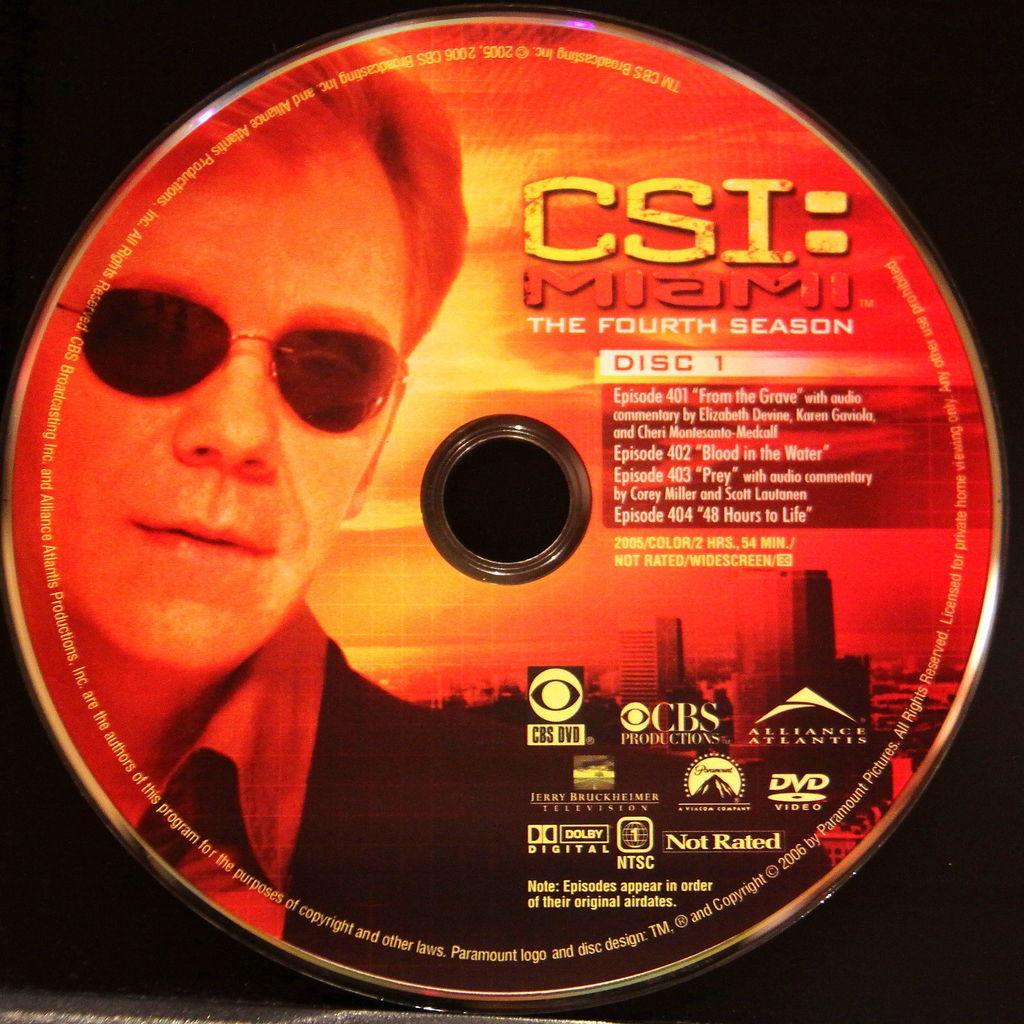In one or two sentences, can you explain what this image depicts? In the image there is a CD and on that CD there is a person´s picture and beside that picture there is some text and logos. 